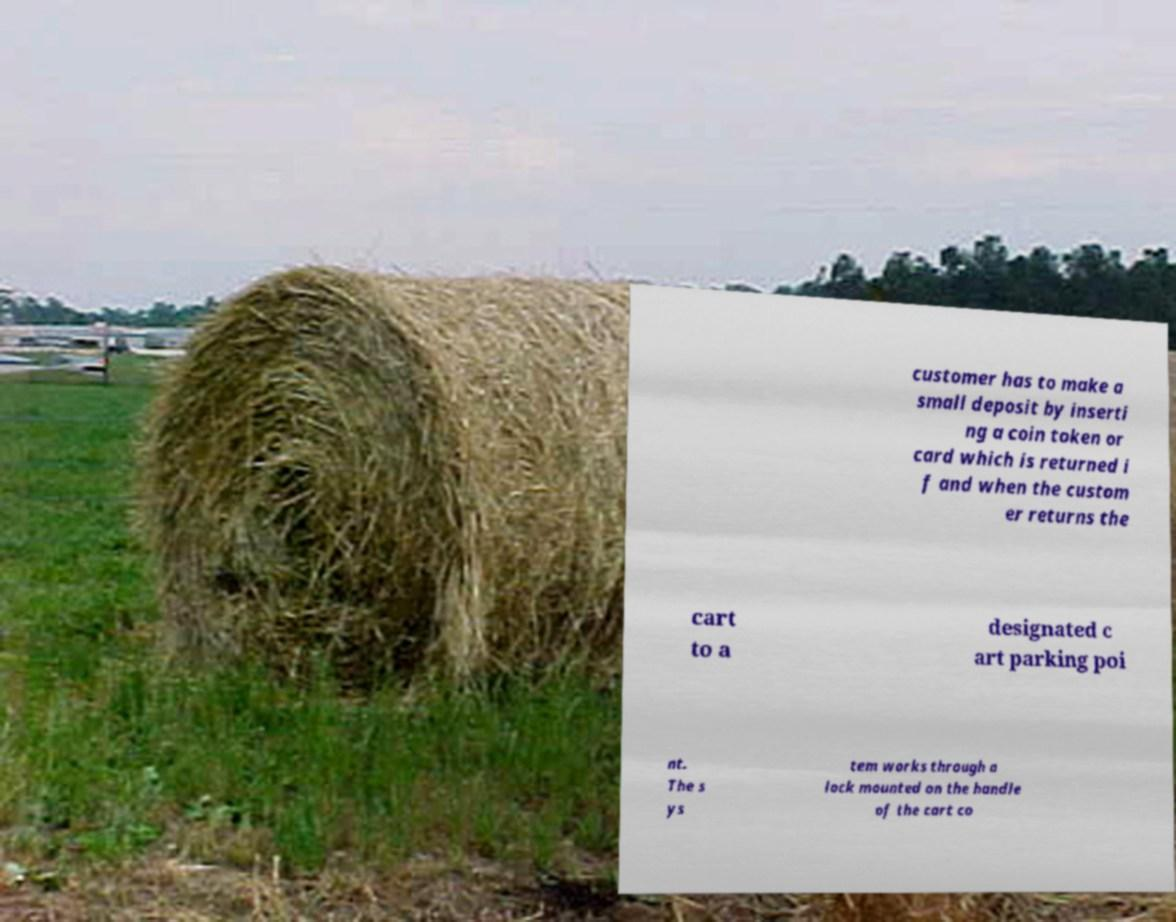Could you assist in decoding the text presented in this image and type it out clearly? customer has to make a small deposit by inserti ng a coin token or card which is returned i f and when the custom er returns the cart to a designated c art parking poi nt. The s ys tem works through a lock mounted on the handle of the cart co 